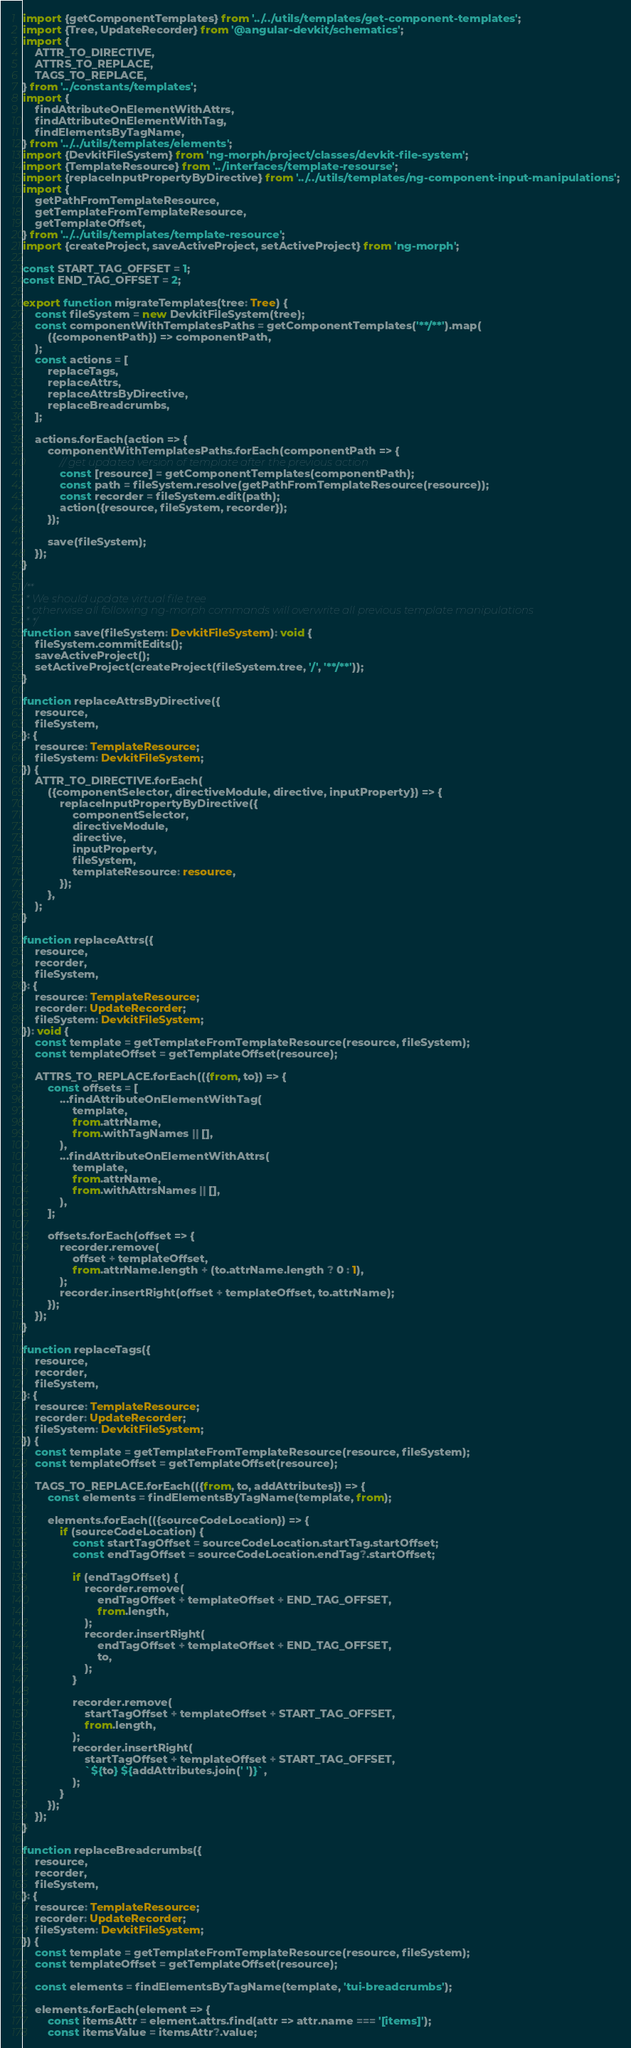Convert code to text. <code><loc_0><loc_0><loc_500><loc_500><_TypeScript_>import {getComponentTemplates} from '../../utils/templates/get-component-templates';
import {Tree, UpdateRecorder} from '@angular-devkit/schematics';
import {
    ATTR_TO_DIRECTIVE,
    ATTRS_TO_REPLACE,
    TAGS_TO_REPLACE,
} from '../constants/templates';
import {
    findAttributeOnElementWithAttrs,
    findAttributeOnElementWithTag,
    findElementsByTagName,
} from '../../utils/templates/elements';
import {DevkitFileSystem} from 'ng-morph/project/classes/devkit-file-system';
import {TemplateResource} from '../interfaces/template-resourse';
import {replaceInputPropertyByDirective} from '../../utils/templates/ng-component-input-manipulations';
import {
    getPathFromTemplateResource,
    getTemplateFromTemplateResource,
    getTemplateOffset,
} from '../../utils/templates/template-resource';
import {createProject, saveActiveProject, setActiveProject} from 'ng-morph';

const START_TAG_OFFSET = 1;
const END_TAG_OFFSET = 2;

export function migrateTemplates(tree: Tree) {
    const fileSystem = new DevkitFileSystem(tree);
    const componentWithTemplatesPaths = getComponentTemplates('**/**').map(
        ({componentPath}) => componentPath,
    );
    const actions = [
        replaceTags,
        replaceAttrs,
        replaceAttrsByDirective,
        replaceBreadcrumbs,
    ];

    actions.forEach(action => {
        componentWithTemplatesPaths.forEach(componentPath => {
            // get updated version of template after the previous action
            const [resource] = getComponentTemplates(componentPath);
            const path = fileSystem.resolve(getPathFromTemplateResource(resource));
            const recorder = fileSystem.edit(path);
            action({resource, fileSystem, recorder});
        });

        save(fileSystem);
    });
}

/**
 * We should update virtual file tree
 * otherwise all following ng-morph commands will overwrite all previous template manipulations
 * */
function save(fileSystem: DevkitFileSystem): void {
    fileSystem.commitEdits();
    saveActiveProject();
    setActiveProject(createProject(fileSystem.tree, '/', '**/**'));
}

function replaceAttrsByDirective({
    resource,
    fileSystem,
}: {
    resource: TemplateResource;
    fileSystem: DevkitFileSystem;
}) {
    ATTR_TO_DIRECTIVE.forEach(
        ({componentSelector, directiveModule, directive, inputProperty}) => {
            replaceInputPropertyByDirective({
                componentSelector,
                directiveModule,
                directive,
                inputProperty,
                fileSystem,
                templateResource: resource,
            });
        },
    );
}

function replaceAttrs({
    resource,
    recorder,
    fileSystem,
}: {
    resource: TemplateResource;
    recorder: UpdateRecorder;
    fileSystem: DevkitFileSystem;
}): void {
    const template = getTemplateFromTemplateResource(resource, fileSystem);
    const templateOffset = getTemplateOffset(resource);

    ATTRS_TO_REPLACE.forEach(({from, to}) => {
        const offsets = [
            ...findAttributeOnElementWithTag(
                template,
                from.attrName,
                from.withTagNames || [],
            ),
            ...findAttributeOnElementWithAttrs(
                template,
                from.attrName,
                from.withAttrsNames || [],
            ),
        ];

        offsets.forEach(offset => {
            recorder.remove(
                offset + templateOffset,
                from.attrName.length + (to.attrName.length ? 0 : 1),
            );
            recorder.insertRight(offset + templateOffset, to.attrName);
        });
    });
}

function replaceTags({
    resource,
    recorder,
    fileSystem,
}: {
    resource: TemplateResource;
    recorder: UpdateRecorder;
    fileSystem: DevkitFileSystem;
}) {
    const template = getTemplateFromTemplateResource(resource, fileSystem);
    const templateOffset = getTemplateOffset(resource);

    TAGS_TO_REPLACE.forEach(({from, to, addAttributes}) => {
        const elements = findElementsByTagName(template, from);

        elements.forEach(({sourceCodeLocation}) => {
            if (sourceCodeLocation) {
                const startTagOffset = sourceCodeLocation.startTag.startOffset;
                const endTagOffset = sourceCodeLocation.endTag?.startOffset;

                if (endTagOffset) {
                    recorder.remove(
                        endTagOffset + templateOffset + END_TAG_OFFSET,
                        from.length,
                    );
                    recorder.insertRight(
                        endTagOffset + templateOffset + END_TAG_OFFSET,
                        to,
                    );
                }

                recorder.remove(
                    startTagOffset + templateOffset + START_TAG_OFFSET,
                    from.length,
                );
                recorder.insertRight(
                    startTagOffset + templateOffset + START_TAG_OFFSET,
                    `${to} ${addAttributes.join(' ')}`,
                );
            }
        });
    });
}

function replaceBreadcrumbs({
    resource,
    recorder,
    fileSystem,
}: {
    resource: TemplateResource;
    recorder: UpdateRecorder;
    fileSystem: DevkitFileSystem;
}) {
    const template = getTemplateFromTemplateResource(resource, fileSystem);
    const templateOffset = getTemplateOffset(resource);

    const elements = findElementsByTagName(template, 'tui-breadcrumbs');

    elements.forEach(element => {
        const itemsAttr = element.attrs.find(attr => attr.name === '[items]');
        const itemsValue = itemsAttr?.value;</code> 